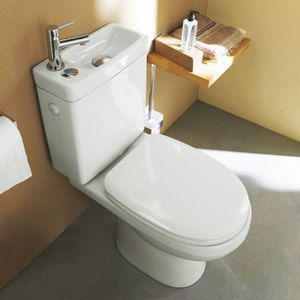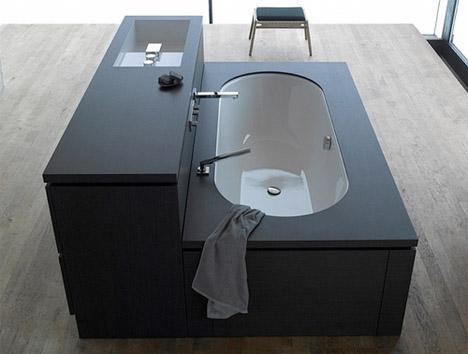The first image is the image on the left, the second image is the image on the right. Examine the images to the left and right. Is the description "At least one toilet is visible in every picture and all toilets have their lids closed." accurate? Answer yes or no. No. The first image is the image on the left, the second image is the image on the right. Considering the images on both sides, is "In at least on image there is a single pearl white toilet facing forward right with a sink on top." valid? Answer yes or no. Yes. 